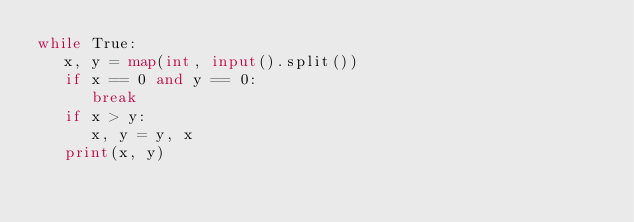Convert code to text. <code><loc_0><loc_0><loc_500><loc_500><_Python_>while True:
   x, y = map(int, input().split())
   if x == 0 and y == 0:
      break
   if x > y:
      x, y = y, x      
   print(x, y)
</code> 